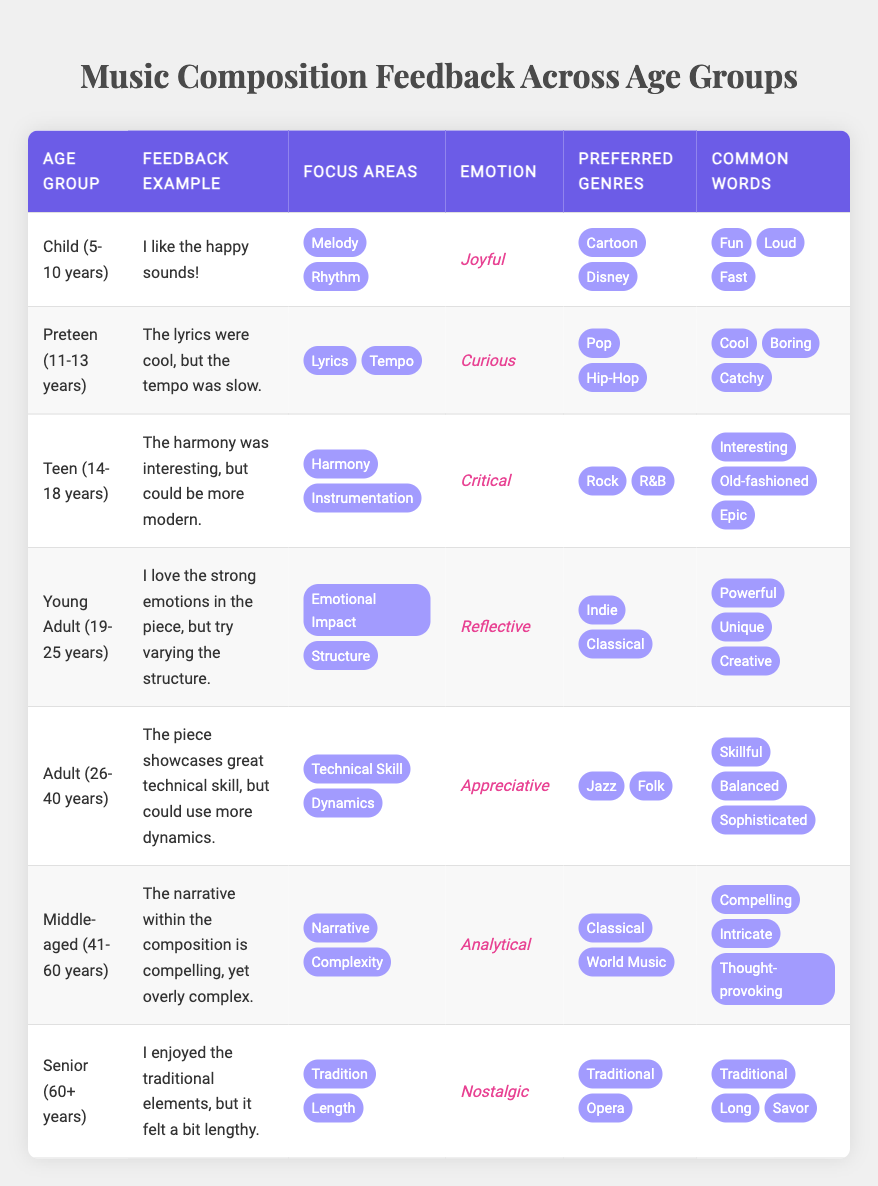What feedback example did the Preteen group give? The Preteen group provided the feedback example: "The lyrics were cool, but the tempo was slow." This information is directly retrieved from the table under the "Feedback Example" column for the "Preteen (11-13 years)" row.
Answer: The lyrics were cool, but the tempo was slow Which emotion is associated with the feedback from the Young Adult group? The Young Adult group has the emotion "Reflective." This can be found in the corresponding row for Young Adults in the "Emotion" column of the table.
Answer: Reflective Are the preferred genres of the Adult group Jazz or Urban? The preferred genres listed for the Adult group (26-40 years) are "Jazz" and "Folk." Since Urban is not on the list provided, the statement is false. Thus, the answer is based on checking the "Preferred Genres" column for the Adult group.
Answer: No Which age group prefers Cartoon and Disney music? The age group that prefers Cartoon and Disney music is "Child (5-10 years)." This can be found in the "Preferred Genres" column for the respective age group.
Answer: Child (5-10 years) What is the common word used by the Senior group? The Senior group used common words including "Traditional," "Long," and "Savor." This information is retrieved from the "Common Words" column under the "Senior (60+ years)" row.
Answer: Traditional, Long, Savor What is the average number of focus areas across all age groups listed? By counting the focus areas listed for each age group, we find that there are 6 groups with 2 focus areas each, totaling 12 focus areas. Then dividing by 7 age groups gives an average of 12/7 = 1.71. Thus, the average number of focus areas is computed as follows: total count is 12, divided by the number of age groups (7), results in an average of 1.71.
Answer: 1.71 Which feedback example indicates a nostalgic emotional response? The feedback example that indicates a nostalgic emotional response is attributed to the Senior group. The connected example is: "I enjoyed the traditional elements, but it felt a bit lengthy." This is directly pulled from the "Feedback Example" column under the "Senior (60+ years)" row.
Answer: I enjoyed the traditional elements, but it felt a bit lengthy Is the analysis from the Middle-aged group focused more on narrative or instrumentation? The analysis from the Middle-aged group indicates a focus on "Narrative" and "Complexity." This means the focus is not on instrumentation, which is confirmed by checking the "Focus Areas" column for that group.
Answer: Yes, it's focused on narrative 